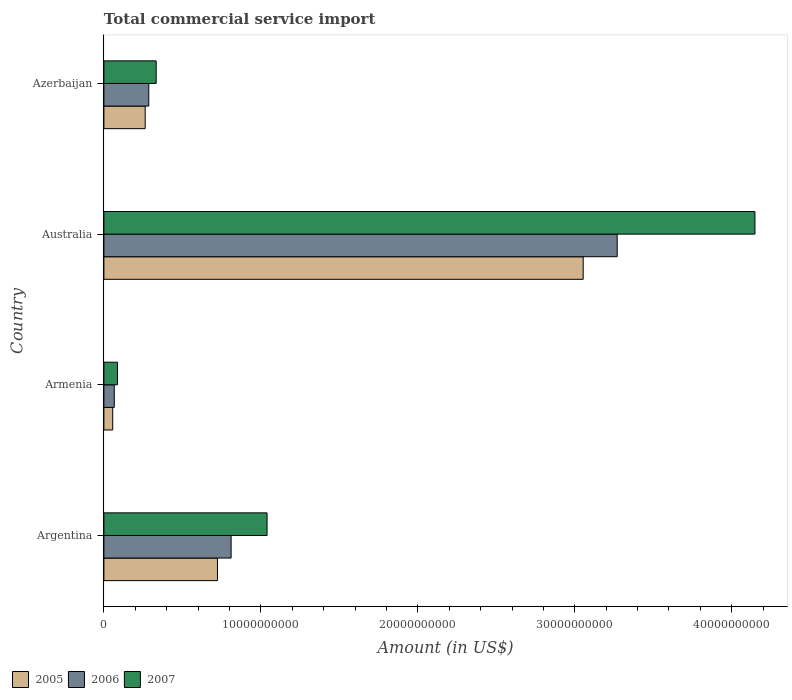Are the number of bars per tick equal to the number of legend labels?
Provide a succinct answer. Yes. How many bars are there on the 4th tick from the top?
Your answer should be compact. 3. What is the total commercial service import in 2007 in Azerbaijan?
Provide a short and direct response. 3.33e+09. Across all countries, what is the maximum total commercial service import in 2006?
Make the answer very short. 3.27e+1. Across all countries, what is the minimum total commercial service import in 2005?
Offer a terse response. 5.61e+08. In which country was the total commercial service import in 2007 maximum?
Your response must be concise. Australia. In which country was the total commercial service import in 2005 minimum?
Your answer should be compact. Armenia. What is the total total commercial service import in 2005 in the graph?
Provide a succinct answer. 4.10e+1. What is the difference between the total commercial service import in 2007 in Argentina and that in Australia?
Give a very brief answer. -3.11e+1. What is the difference between the total commercial service import in 2006 in Armenia and the total commercial service import in 2007 in Australia?
Provide a succinct answer. -4.08e+1. What is the average total commercial service import in 2007 per country?
Give a very brief answer. 1.40e+1. What is the difference between the total commercial service import in 2007 and total commercial service import in 2005 in Armenia?
Your response must be concise. 3.03e+08. In how many countries, is the total commercial service import in 2006 greater than 40000000000 US$?
Make the answer very short. 0. What is the ratio of the total commercial service import in 2006 in Argentina to that in Australia?
Your answer should be compact. 0.25. Is the difference between the total commercial service import in 2007 in Argentina and Australia greater than the difference between the total commercial service import in 2005 in Argentina and Australia?
Your response must be concise. No. What is the difference between the highest and the second highest total commercial service import in 2005?
Ensure brevity in your answer.  2.33e+1. What is the difference between the highest and the lowest total commercial service import in 2007?
Ensure brevity in your answer.  4.06e+1. Is the sum of the total commercial service import in 2006 in Argentina and Armenia greater than the maximum total commercial service import in 2007 across all countries?
Give a very brief answer. No. What does the 3rd bar from the top in Armenia represents?
Offer a terse response. 2005. What does the 2nd bar from the bottom in Azerbaijan represents?
Give a very brief answer. 2006. Is it the case that in every country, the sum of the total commercial service import in 2007 and total commercial service import in 2006 is greater than the total commercial service import in 2005?
Provide a succinct answer. Yes. How many bars are there?
Ensure brevity in your answer.  12. Are all the bars in the graph horizontal?
Give a very brief answer. Yes. How many countries are there in the graph?
Your answer should be compact. 4. What is the difference between two consecutive major ticks on the X-axis?
Keep it short and to the point. 1.00e+1. Are the values on the major ticks of X-axis written in scientific E-notation?
Your response must be concise. No. Does the graph contain grids?
Ensure brevity in your answer.  No. Where does the legend appear in the graph?
Your answer should be compact. Bottom left. What is the title of the graph?
Your answer should be compact. Total commercial service import. What is the label or title of the X-axis?
Your answer should be compact. Amount (in US$). What is the Amount (in US$) of 2005 in Argentina?
Provide a succinct answer. 7.24e+09. What is the Amount (in US$) of 2006 in Argentina?
Give a very brief answer. 8.10e+09. What is the Amount (in US$) of 2007 in Argentina?
Ensure brevity in your answer.  1.04e+1. What is the Amount (in US$) of 2005 in Armenia?
Offer a terse response. 5.61e+08. What is the Amount (in US$) of 2006 in Armenia?
Ensure brevity in your answer.  6.62e+08. What is the Amount (in US$) in 2007 in Armenia?
Make the answer very short. 8.64e+08. What is the Amount (in US$) of 2005 in Australia?
Offer a terse response. 3.05e+1. What is the Amount (in US$) in 2006 in Australia?
Give a very brief answer. 3.27e+1. What is the Amount (in US$) in 2007 in Australia?
Offer a terse response. 4.15e+1. What is the Amount (in US$) in 2005 in Azerbaijan?
Your response must be concise. 2.63e+09. What is the Amount (in US$) in 2006 in Azerbaijan?
Provide a short and direct response. 2.86e+09. What is the Amount (in US$) of 2007 in Azerbaijan?
Give a very brief answer. 3.33e+09. Across all countries, what is the maximum Amount (in US$) in 2005?
Your answer should be very brief. 3.05e+1. Across all countries, what is the maximum Amount (in US$) in 2006?
Your response must be concise. 3.27e+1. Across all countries, what is the maximum Amount (in US$) in 2007?
Give a very brief answer. 4.15e+1. Across all countries, what is the minimum Amount (in US$) in 2005?
Your response must be concise. 5.61e+08. Across all countries, what is the minimum Amount (in US$) of 2006?
Provide a succinct answer. 6.62e+08. Across all countries, what is the minimum Amount (in US$) in 2007?
Your answer should be compact. 8.64e+08. What is the total Amount (in US$) of 2005 in the graph?
Keep it short and to the point. 4.10e+1. What is the total Amount (in US$) in 2006 in the graph?
Ensure brevity in your answer.  4.43e+1. What is the total Amount (in US$) in 2007 in the graph?
Your response must be concise. 5.61e+1. What is the difference between the Amount (in US$) in 2005 in Argentina and that in Armenia?
Provide a succinct answer. 6.67e+09. What is the difference between the Amount (in US$) in 2006 in Argentina and that in Armenia?
Your response must be concise. 7.44e+09. What is the difference between the Amount (in US$) of 2007 in Argentina and that in Armenia?
Keep it short and to the point. 9.53e+09. What is the difference between the Amount (in US$) in 2005 in Argentina and that in Australia?
Provide a short and direct response. -2.33e+1. What is the difference between the Amount (in US$) in 2006 in Argentina and that in Australia?
Provide a succinct answer. -2.46e+1. What is the difference between the Amount (in US$) in 2007 in Argentina and that in Australia?
Give a very brief answer. -3.11e+1. What is the difference between the Amount (in US$) in 2005 in Argentina and that in Azerbaijan?
Your answer should be compact. 4.60e+09. What is the difference between the Amount (in US$) of 2006 in Argentina and that in Azerbaijan?
Ensure brevity in your answer.  5.25e+09. What is the difference between the Amount (in US$) of 2007 in Argentina and that in Azerbaijan?
Keep it short and to the point. 7.06e+09. What is the difference between the Amount (in US$) in 2005 in Armenia and that in Australia?
Your answer should be very brief. -3.00e+1. What is the difference between the Amount (in US$) of 2006 in Armenia and that in Australia?
Provide a succinct answer. -3.20e+1. What is the difference between the Amount (in US$) of 2007 in Armenia and that in Australia?
Your answer should be compact. -4.06e+1. What is the difference between the Amount (in US$) of 2005 in Armenia and that in Azerbaijan?
Your response must be concise. -2.07e+09. What is the difference between the Amount (in US$) of 2006 in Armenia and that in Azerbaijan?
Give a very brief answer. -2.20e+09. What is the difference between the Amount (in US$) in 2007 in Armenia and that in Azerbaijan?
Offer a very short reply. -2.47e+09. What is the difference between the Amount (in US$) in 2005 in Australia and that in Azerbaijan?
Keep it short and to the point. 2.79e+1. What is the difference between the Amount (in US$) of 2006 in Australia and that in Azerbaijan?
Provide a short and direct response. 2.98e+1. What is the difference between the Amount (in US$) of 2007 in Australia and that in Azerbaijan?
Ensure brevity in your answer.  3.81e+1. What is the difference between the Amount (in US$) of 2005 in Argentina and the Amount (in US$) of 2006 in Armenia?
Give a very brief answer. 6.57e+09. What is the difference between the Amount (in US$) of 2005 in Argentina and the Amount (in US$) of 2007 in Armenia?
Keep it short and to the point. 6.37e+09. What is the difference between the Amount (in US$) of 2006 in Argentina and the Amount (in US$) of 2007 in Armenia?
Provide a short and direct response. 7.24e+09. What is the difference between the Amount (in US$) of 2005 in Argentina and the Amount (in US$) of 2006 in Australia?
Give a very brief answer. -2.55e+1. What is the difference between the Amount (in US$) in 2005 in Argentina and the Amount (in US$) in 2007 in Australia?
Provide a short and direct response. -3.42e+1. What is the difference between the Amount (in US$) of 2006 in Argentina and the Amount (in US$) of 2007 in Australia?
Give a very brief answer. -3.34e+1. What is the difference between the Amount (in US$) of 2005 in Argentina and the Amount (in US$) of 2006 in Azerbaijan?
Keep it short and to the point. 4.38e+09. What is the difference between the Amount (in US$) of 2005 in Argentina and the Amount (in US$) of 2007 in Azerbaijan?
Your answer should be very brief. 3.90e+09. What is the difference between the Amount (in US$) in 2006 in Argentina and the Amount (in US$) in 2007 in Azerbaijan?
Your response must be concise. 4.77e+09. What is the difference between the Amount (in US$) of 2005 in Armenia and the Amount (in US$) of 2006 in Australia?
Your answer should be compact. -3.21e+1. What is the difference between the Amount (in US$) of 2005 in Armenia and the Amount (in US$) of 2007 in Australia?
Provide a succinct answer. -4.09e+1. What is the difference between the Amount (in US$) in 2006 in Armenia and the Amount (in US$) in 2007 in Australia?
Provide a succinct answer. -4.08e+1. What is the difference between the Amount (in US$) of 2005 in Armenia and the Amount (in US$) of 2006 in Azerbaijan?
Keep it short and to the point. -2.30e+09. What is the difference between the Amount (in US$) of 2005 in Armenia and the Amount (in US$) of 2007 in Azerbaijan?
Ensure brevity in your answer.  -2.77e+09. What is the difference between the Amount (in US$) of 2006 in Armenia and the Amount (in US$) of 2007 in Azerbaijan?
Provide a short and direct response. -2.67e+09. What is the difference between the Amount (in US$) in 2005 in Australia and the Amount (in US$) in 2006 in Azerbaijan?
Your answer should be compact. 2.77e+1. What is the difference between the Amount (in US$) of 2005 in Australia and the Amount (in US$) of 2007 in Azerbaijan?
Keep it short and to the point. 2.72e+1. What is the difference between the Amount (in US$) of 2006 in Australia and the Amount (in US$) of 2007 in Azerbaijan?
Your answer should be very brief. 2.94e+1. What is the average Amount (in US$) in 2005 per country?
Ensure brevity in your answer.  1.02e+1. What is the average Amount (in US$) of 2006 per country?
Provide a short and direct response. 1.11e+1. What is the average Amount (in US$) of 2007 per country?
Provide a short and direct response. 1.40e+1. What is the difference between the Amount (in US$) of 2005 and Amount (in US$) of 2006 in Argentina?
Your response must be concise. -8.69e+08. What is the difference between the Amount (in US$) of 2005 and Amount (in US$) of 2007 in Argentina?
Offer a terse response. -3.16e+09. What is the difference between the Amount (in US$) of 2006 and Amount (in US$) of 2007 in Argentina?
Ensure brevity in your answer.  -2.29e+09. What is the difference between the Amount (in US$) in 2005 and Amount (in US$) in 2006 in Armenia?
Offer a terse response. -1.01e+08. What is the difference between the Amount (in US$) of 2005 and Amount (in US$) of 2007 in Armenia?
Your response must be concise. -3.03e+08. What is the difference between the Amount (in US$) in 2006 and Amount (in US$) in 2007 in Armenia?
Your response must be concise. -2.02e+08. What is the difference between the Amount (in US$) of 2005 and Amount (in US$) of 2006 in Australia?
Offer a terse response. -2.17e+09. What is the difference between the Amount (in US$) of 2005 and Amount (in US$) of 2007 in Australia?
Your response must be concise. -1.09e+1. What is the difference between the Amount (in US$) of 2006 and Amount (in US$) of 2007 in Australia?
Give a very brief answer. -8.78e+09. What is the difference between the Amount (in US$) in 2005 and Amount (in US$) in 2006 in Azerbaijan?
Provide a short and direct response. -2.28e+08. What is the difference between the Amount (in US$) of 2005 and Amount (in US$) of 2007 in Azerbaijan?
Provide a succinct answer. -7.00e+08. What is the difference between the Amount (in US$) in 2006 and Amount (in US$) in 2007 in Azerbaijan?
Your answer should be very brief. -4.72e+08. What is the ratio of the Amount (in US$) in 2005 in Argentina to that in Armenia?
Keep it short and to the point. 12.89. What is the ratio of the Amount (in US$) in 2006 in Argentina to that in Armenia?
Ensure brevity in your answer.  12.24. What is the ratio of the Amount (in US$) in 2007 in Argentina to that in Armenia?
Your answer should be very brief. 12.03. What is the ratio of the Amount (in US$) of 2005 in Argentina to that in Australia?
Offer a terse response. 0.24. What is the ratio of the Amount (in US$) of 2006 in Argentina to that in Australia?
Provide a short and direct response. 0.25. What is the ratio of the Amount (in US$) of 2007 in Argentina to that in Australia?
Keep it short and to the point. 0.25. What is the ratio of the Amount (in US$) of 2005 in Argentina to that in Azerbaijan?
Ensure brevity in your answer.  2.75. What is the ratio of the Amount (in US$) in 2006 in Argentina to that in Azerbaijan?
Ensure brevity in your answer.  2.83. What is the ratio of the Amount (in US$) of 2007 in Argentina to that in Azerbaijan?
Provide a short and direct response. 3.12. What is the ratio of the Amount (in US$) of 2005 in Armenia to that in Australia?
Provide a short and direct response. 0.02. What is the ratio of the Amount (in US$) in 2006 in Armenia to that in Australia?
Provide a succinct answer. 0.02. What is the ratio of the Amount (in US$) of 2007 in Armenia to that in Australia?
Your response must be concise. 0.02. What is the ratio of the Amount (in US$) in 2005 in Armenia to that in Azerbaijan?
Your answer should be compact. 0.21. What is the ratio of the Amount (in US$) of 2006 in Armenia to that in Azerbaijan?
Make the answer very short. 0.23. What is the ratio of the Amount (in US$) in 2007 in Armenia to that in Azerbaijan?
Give a very brief answer. 0.26. What is the ratio of the Amount (in US$) of 2005 in Australia to that in Azerbaijan?
Keep it short and to the point. 11.61. What is the ratio of the Amount (in US$) of 2006 in Australia to that in Azerbaijan?
Make the answer very short. 11.44. What is the ratio of the Amount (in US$) in 2007 in Australia to that in Azerbaijan?
Your answer should be compact. 12.45. What is the difference between the highest and the second highest Amount (in US$) of 2005?
Make the answer very short. 2.33e+1. What is the difference between the highest and the second highest Amount (in US$) of 2006?
Keep it short and to the point. 2.46e+1. What is the difference between the highest and the second highest Amount (in US$) of 2007?
Provide a short and direct response. 3.11e+1. What is the difference between the highest and the lowest Amount (in US$) in 2005?
Your response must be concise. 3.00e+1. What is the difference between the highest and the lowest Amount (in US$) in 2006?
Make the answer very short. 3.20e+1. What is the difference between the highest and the lowest Amount (in US$) of 2007?
Provide a short and direct response. 4.06e+1. 